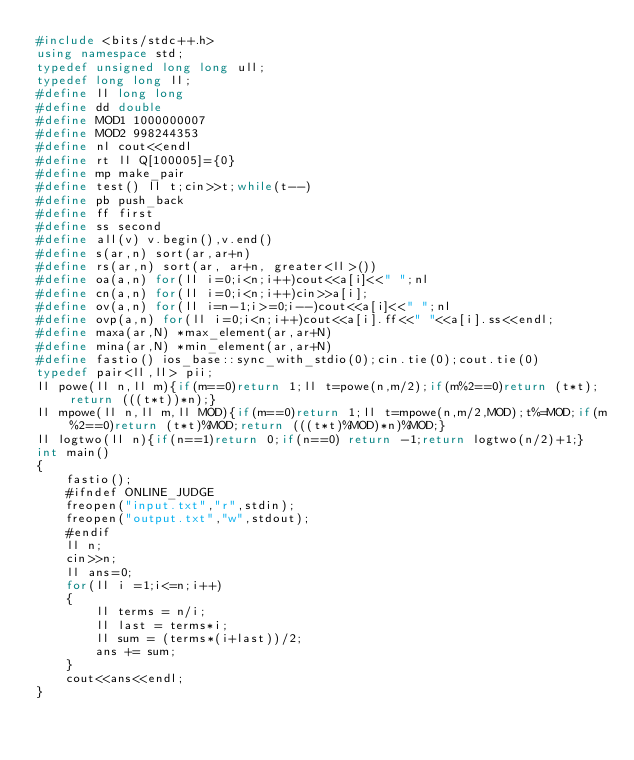<code> <loc_0><loc_0><loc_500><loc_500><_C++_>#include <bits/stdc++.h>
using namespace std;
typedef unsigned long long ull;
typedef long long ll;
#define ll long long
#define dd double
#define MOD1 1000000007
#define MOD2 998244353
#define nl cout<<endl
#define rt ll Q[100005]={0}
#define mp make_pair
#define test() ll t;cin>>t;while(t--)
#define pb push_back
#define ff first    
#define ss second
#define all(v) v.begin(),v.end()
#define s(ar,n) sort(ar,ar+n)
#define rs(ar,n) sort(ar, ar+n, greater<ll>()) 
#define oa(a,n) for(ll i=0;i<n;i++)cout<<a[i]<<" ";nl
#define cn(a,n) for(ll i=0;i<n;i++)cin>>a[i];
#define ov(a,n) for(ll i=n-1;i>=0;i--)cout<<a[i]<<" ";nl
#define ovp(a,n) for(ll i=0;i<n;i++)cout<<a[i].ff<<" "<<a[i].ss<<endl;
#define maxa(ar,N) *max_element(ar,ar+N)
#define mina(ar,N) *min_element(ar,ar+N)
#define fastio() ios_base::sync_with_stdio(0);cin.tie(0);cout.tie(0)
typedef pair<ll,ll> pii;
ll powe(ll n,ll m){if(m==0)return 1;ll t=powe(n,m/2);if(m%2==0)return (t*t);return (((t*t))*n);}
ll mpowe(ll n,ll m,ll MOD){if(m==0)return 1;ll t=mpowe(n,m/2,MOD);t%=MOD;if(m%2==0)return (t*t)%MOD;return (((t*t)%MOD)*n)%MOD;}
ll logtwo(ll n){if(n==1)return 0;if(n==0) return -1;return logtwo(n/2)+1;}
int main()
{
    fastio();
    #ifndef ONLINE_JUDGE
    freopen("input.txt","r",stdin);
    freopen("output.txt","w",stdout);
    #endif
    ll n;
    cin>>n;
    ll ans=0;
    for(ll i =1;i<=n;i++)
    {
        ll terms = n/i;
        ll last = terms*i;
        ll sum = (terms*(i+last))/2;
        ans += sum;
    }
    cout<<ans<<endl;
}</code> 